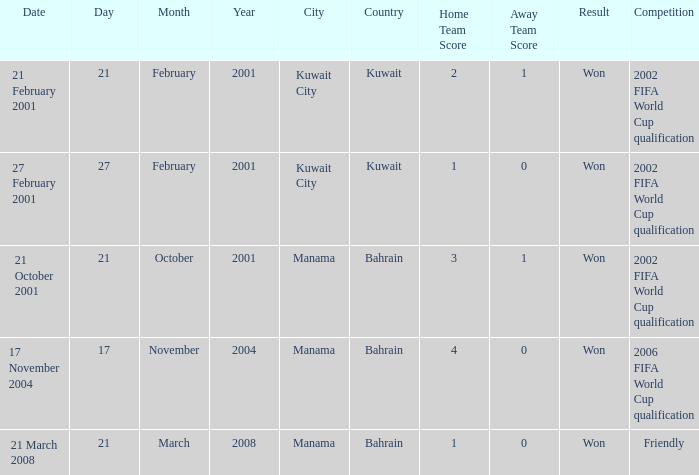On which date was the match in Manama, Bahrain? 21 October 2001, 17 November 2004, 21 March 2008. Parse the full table. {'header': ['Date', 'Day', 'Month', 'Year', 'City', 'Country', 'Home Team Score', 'Away Team Score', 'Result', 'Competition'], 'rows': [['21 February 2001', '21', 'February', '2001', 'Kuwait City', 'Kuwait', '2', '1', 'Won', '2002 FIFA World Cup qualification'], ['27 February 2001', '27', 'February', '2001', 'Kuwait City', 'Kuwait', '1', '0', 'Won', '2002 FIFA World Cup qualification'], ['21 October 2001', '21', 'October', '2001', 'Manama', 'Bahrain', '3', '1', 'Won', '2002 FIFA World Cup qualification'], ['17 November 2004', '17', 'November', '2004', 'Manama', 'Bahrain', '4', '0', 'Won', '2006 FIFA World Cup qualification'], ['21 March 2008', '21', 'March', '2008', 'Manama', 'Bahrain', '1', '0', 'Won', 'Friendly']]} 